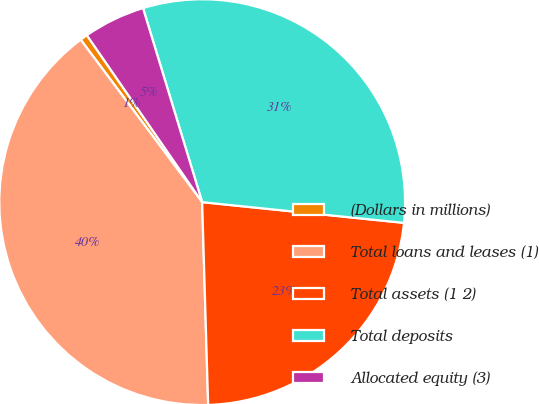<chart> <loc_0><loc_0><loc_500><loc_500><pie_chart><fcel>(Dollars in millions)<fcel>Total loans and leases (1)<fcel>Total assets (1 2)<fcel>Total deposits<fcel>Allocated equity (3)<nl><fcel>0.6%<fcel>40.25%<fcel>22.9%<fcel>31.34%<fcel>4.91%<nl></chart> 